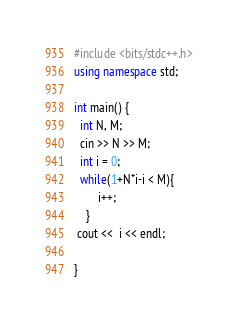<code> <loc_0><loc_0><loc_500><loc_500><_C++_>#include <bits/stdc++.h>
using namespace std;

int main() {
  int N, M;
  cin >> N >> M;
  int i = 0;
  while(1+N*i-i < M){
        i++;
    }
 cout <<  i << endl;  
  
}
</code> 